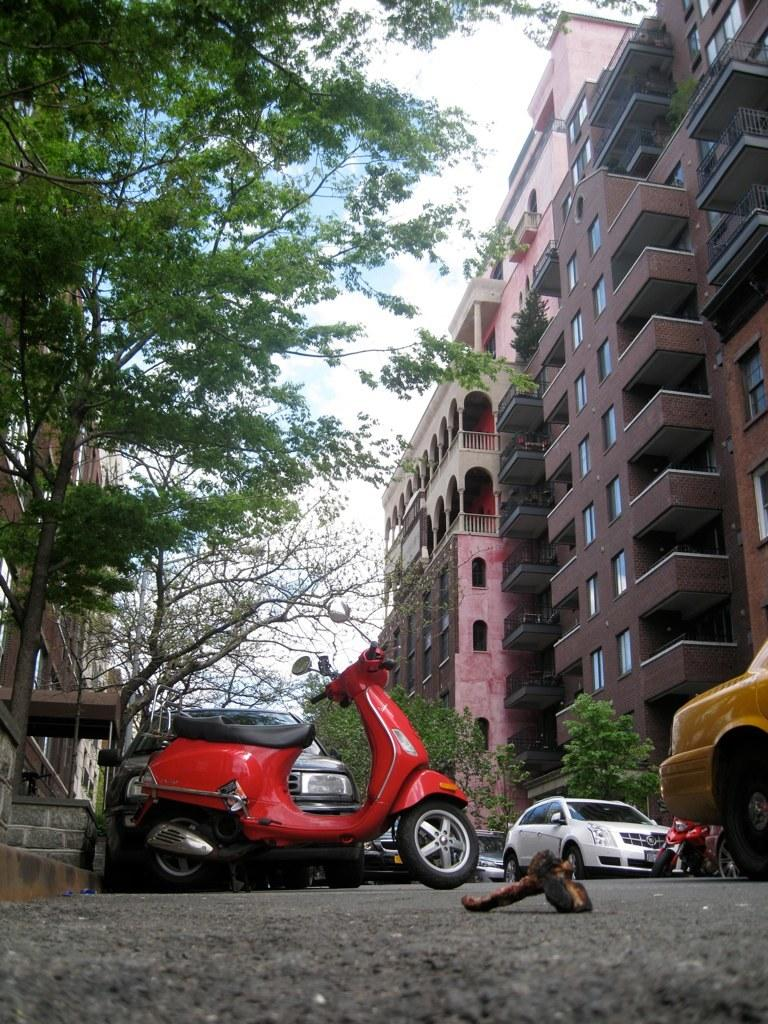What can be seen on the road in the image? There are vehicles on the road in the image. What type of natural elements are present in the image? There are trees in the image. What type of man-made structures can be seen in the image? There are buildings in the image. What feature of the buildings is visible in the image? There are windows visible on the buildings. How would you describe the weather in the image? The sky is cloudy in the image. Can you see any waves crashing on the shore in the image? There is no shore or waves present in the image; it features vehicles on a road, trees, buildings, and a cloudy sky. What type of star can be seen in the image? There are no stars visible in the image; it features a cloudy sky. 